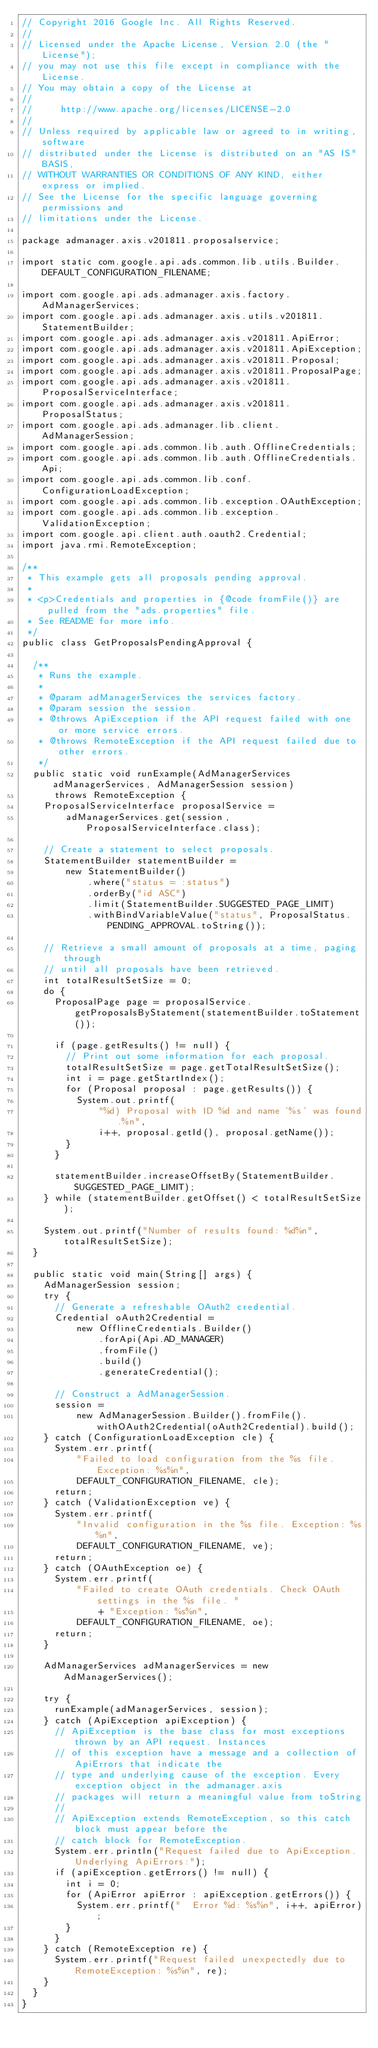<code> <loc_0><loc_0><loc_500><loc_500><_Java_>// Copyright 2016 Google Inc. All Rights Reserved.
//
// Licensed under the Apache License, Version 2.0 (the "License");
// you may not use this file except in compliance with the License.
// You may obtain a copy of the License at
//
//     http://www.apache.org/licenses/LICENSE-2.0
//
// Unless required by applicable law or agreed to in writing, software
// distributed under the License is distributed on an "AS IS" BASIS,
// WITHOUT WARRANTIES OR CONDITIONS OF ANY KIND, either express or implied.
// See the License for the specific language governing permissions and
// limitations under the License.

package admanager.axis.v201811.proposalservice;

import static com.google.api.ads.common.lib.utils.Builder.DEFAULT_CONFIGURATION_FILENAME;

import com.google.api.ads.admanager.axis.factory.AdManagerServices;
import com.google.api.ads.admanager.axis.utils.v201811.StatementBuilder;
import com.google.api.ads.admanager.axis.v201811.ApiError;
import com.google.api.ads.admanager.axis.v201811.ApiException;
import com.google.api.ads.admanager.axis.v201811.Proposal;
import com.google.api.ads.admanager.axis.v201811.ProposalPage;
import com.google.api.ads.admanager.axis.v201811.ProposalServiceInterface;
import com.google.api.ads.admanager.axis.v201811.ProposalStatus;
import com.google.api.ads.admanager.lib.client.AdManagerSession;
import com.google.api.ads.common.lib.auth.OfflineCredentials;
import com.google.api.ads.common.lib.auth.OfflineCredentials.Api;
import com.google.api.ads.common.lib.conf.ConfigurationLoadException;
import com.google.api.ads.common.lib.exception.OAuthException;
import com.google.api.ads.common.lib.exception.ValidationException;
import com.google.api.client.auth.oauth2.Credential;
import java.rmi.RemoteException;

/**
 * This example gets all proposals pending approval.
 *
 * <p>Credentials and properties in {@code fromFile()} are pulled from the "ads.properties" file.
 * See README for more info.
 */
public class GetProposalsPendingApproval {

  /**
   * Runs the example.
   *
   * @param adManagerServices the services factory.
   * @param session the session.
   * @throws ApiException if the API request failed with one or more service errors.
   * @throws RemoteException if the API request failed due to other errors.
   */
  public static void runExample(AdManagerServices adManagerServices, AdManagerSession session)
      throws RemoteException {
    ProposalServiceInterface proposalService =
        adManagerServices.get(session, ProposalServiceInterface.class);

    // Create a statement to select proposals.
    StatementBuilder statementBuilder =
        new StatementBuilder()
            .where("status = :status")
            .orderBy("id ASC")
            .limit(StatementBuilder.SUGGESTED_PAGE_LIMIT)
            .withBindVariableValue("status", ProposalStatus.PENDING_APPROVAL.toString());

    // Retrieve a small amount of proposals at a time, paging through
    // until all proposals have been retrieved.
    int totalResultSetSize = 0;
    do {
      ProposalPage page = proposalService.getProposalsByStatement(statementBuilder.toStatement());

      if (page.getResults() != null) {
        // Print out some information for each proposal.
        totalResultSetSize = page.getTotalResultSetSize();
        int i = page.getStartIndex();
        for (Proposal proposal : page.getResults()) {
          System.out.printf(
              "%d) Proposal with ID %d and name '%s' was found.%n",
              i++, proposal.getId(), proposal.getName());
        }
      }

      statementBuilder.increaseOffsetBy(StatementBuilder.SUGGESTED_PAGE_LIMIT);
    } while (statementBuilder.getOffset() < totalResultSetSize);

    System.out.printf("Number of results found: %d%n", totalResultSetSize);
  }

  public static void main(String[] args) {
    AdManagerSession session;
    try {
      // Generate a refreshable OAuth2 credential.
      Credential oAuth2Credential =
          new OfflineCredentials.Builder()
              .forApi(Api.AD_MANAGER)
              .fromFile()
              .build()
              .generateCredential();

      // Construct a AdManagerSession.
      session =
          new AdManagerSession.Builder().fromFile().withOAuth2Credential(oAuth2Credential).build();
    } catch (ConfigurationLoadException cle) {
      System.err.printf(
          "Failed to load configuration from the %s file. Exception: %s%n",
          DEFAULT_CONFIGURATION_FILENAME, cle);
      return;
    } catch (ValidationException ve) {
      System.err.printf(
          "Invalid configuration in the %s file. Exception: %s%n",
          DEFAULT_CONFIGURATION_FILENAME, ve);
      return;
    } catch (OAuthException oe) {
      System.err.printf(
          "Failed to create OAuth credentials. Check OAuth settings in the %s file. "
              + "Exception: %s%n",
          DEFAULT_CONFIGURATION_FILENAME, oe);
      return;
    }

    AdManagerServices adManagerServices = new AdManagerServices();

    try {
      runExample(adManagerServices, session);
    } catch (ApiException apiException) {
      // ApiException is the base class for most exceptions thrown by an API request. Instances
      // of this exception have a message and a collection of ApiErrors that indicate the
      // type and underlying cause of the exception. Every exception object in the admanager.axis
      // packages will return a meaningful value from toString
      //
      // ApiException extends RemoteException, so this catch block must appear before the
      // catch block for RemoteException.
      System.err.println("Request failed due to ApiException. Underlying ApiErrors:");
      if (apiException.getErrors() != null) {
        int i = 0;
        for (ApiError apiError : apiException.getErrors()) {
          System.err.printf("  Error %d: %s%n", i++, apiError);
        }
      }
    } catch (RemoteException re) {
      System.err.printf("Request failed unexpectedly due to RemoteException: %s%n", re);
    }
  }
}
</code> 